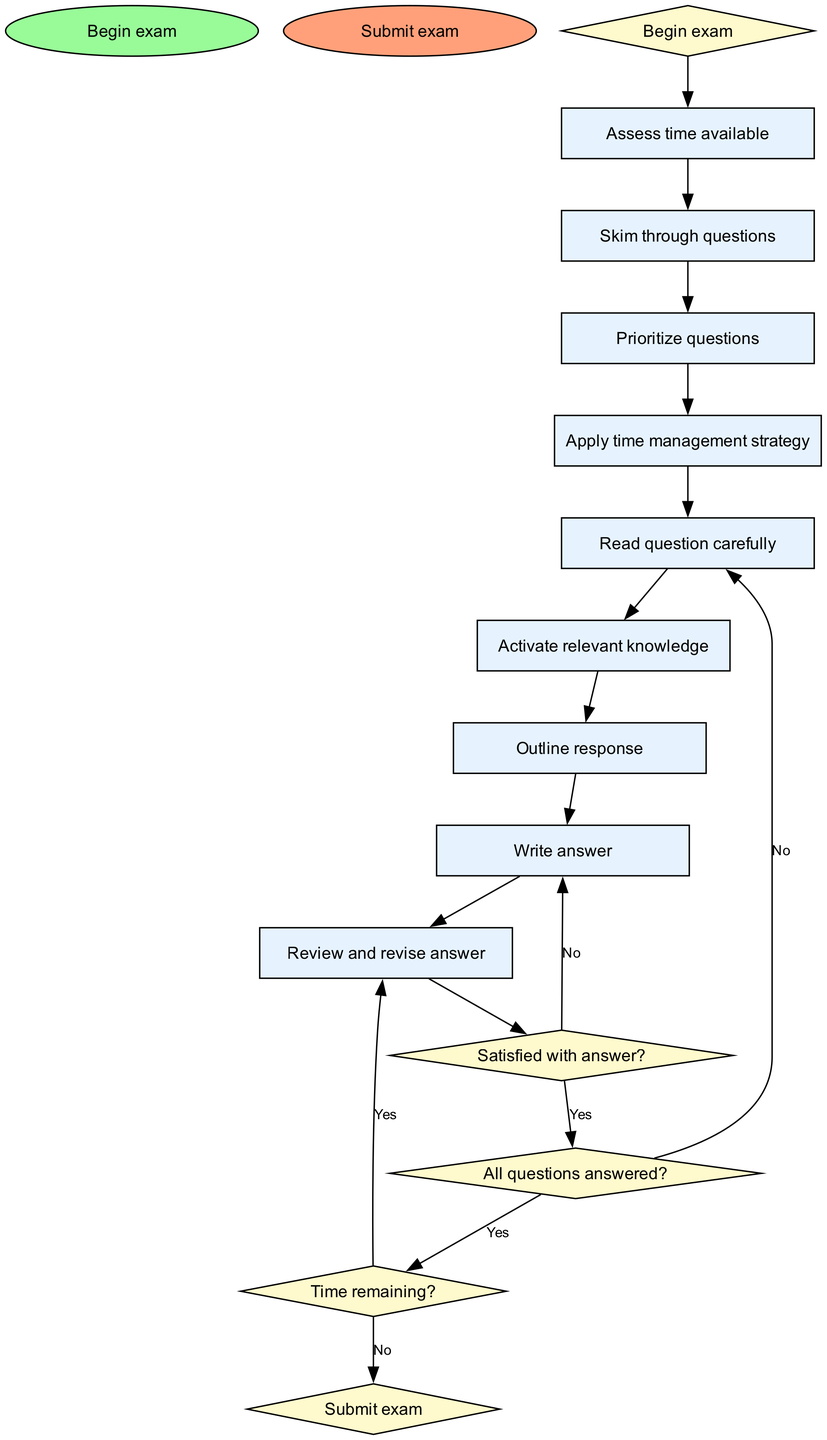What is the starting point of the flow chart? The flow chart begins at the node labeled "Begin exam," indicating the initial step of the process.
Answer: Begin exam How many processes are included in the flow chart? The flow chart contains a total of nine processes, each representing a specific action to be taken during the exam.
Answer: Nine Which node follows the "Assess time available" node? The next node after "Assess time available" is "Skim through questions," indicating the subsequent action in the exam process.
Answer: Skim through questions What happens if the answer is not satisfactory? If a participant is not satisfied with their answer, they go back to the "Write answer" node to revise their response, following the path laid out in the diagram.
Answer: Write answer If all questions are answered, what is the next decision point? When all questions have been answered, the flow moves to the decision point "Time remaining?" where the examinee assesses if they have enough time left to review.
Answer: Time remaining? What is the consequence of not having enough time remaining? If there is not enough time remaining after answering all questions, the final step is to "Submit exam," thus closing the process.
Answer: Submit exam Describe the sequence of actions if the answer is satisfactory and all questions have been answered. If the answer is satisfactory and all questions are answered, the flow moves to the decision "Time remaining?" followed by either reviewing and revising the answer or submitting the exam, depending on time left.
Answer: Review and revise answer or Submit exam Which node is categorized as a decision node? The nodes "Satisfied with answer?", "All questions answered?", and "Time remaining?" are categorized as decision nodes, indicating points where a choice influences the flow of the process.
Answer: Satisfied with answer? What is the end point of the flow chart? The flow chart concludes at the node labeled "Submit exam," representing the final action taken at the end of the examination process.
Answer: Submit exam 